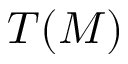Convert formula to latex. <formula><loc_0><loc_0><loc_500><loc_500>T ( M )</formula> 